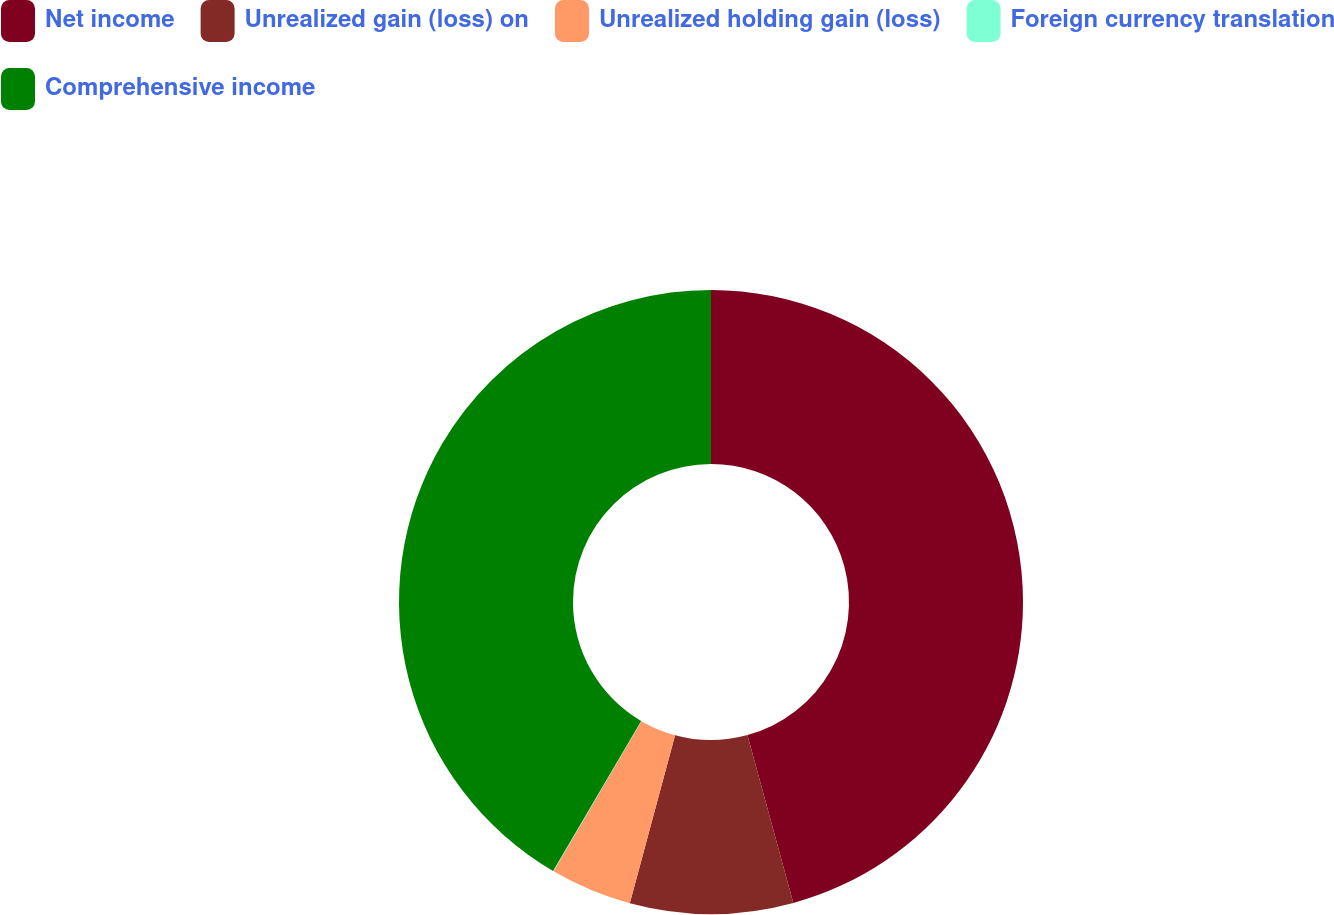Convert chart to OTSL. <chart><loc_0><loc_0><loc_500><loc_500><pie_chart><fcel>Net income<fcel>Unrealized gain (loss) on<fcel>Unrealized holding gain (loss)<fcel>Foreign currency translation<fcel>Comprehensive income<nl><fcel>45.75%<fcel>8.44%<fcel>4.23%<fcel>0.03%<fcel>41.55%<nl></chart> 